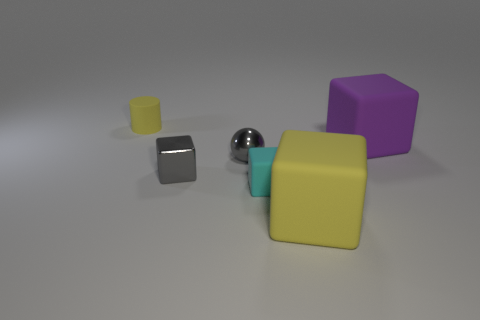There is a yellow matte object that is the same shape as the small cyan matte thing; what size is it?
Provide a succinct answer. Large. Is the color of the ball the same as the tiny metallic block?
Your answer should be very brief. Yes. How many other things are there of the same material as the small yellow cylinder?
Keep it short and to the point. 3. Are there the same number of yellow rubber things that are behind the cyan block and small cyan things?
Your answer should be very brief. Yes. There is a yellow rubber cube to the right of the metal cube; does it have the same size as the tiny cylinder?
Your answer should be very brief. No. There is a matte cylinder; how many tiny rubber objects are to the right of it?
Make the answer very short. 1. What is the thing that is left of the big yellow rubber block and in front of the shiny cube made of?
Your answer should be compact. Rubber. What number of tiny objects are either brown rubber cylinders or cyan cubes?
Keep it short and to the point. 1. The ball has what size?
Keep it short and to the point. Small. What is the shape of the tiny cyan thing?
Give a very brief answer. Cube. 